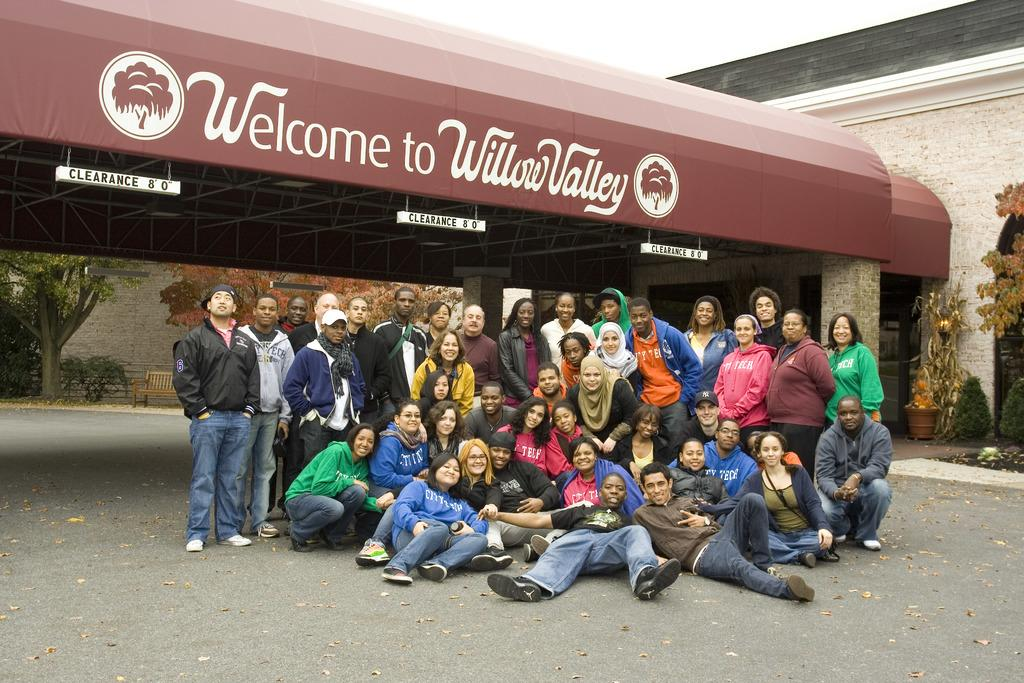What is the main subject of the image? There is a group of people in the middle of the image. What can be seen in the background of the image? There is a shelter, trees, and a wall in the background of the image. What is visible at the top of the image? The sky is visible at the top of the image. Can you tell me how many snakes are slithering around the group of people in the image? There are no snakes present in the image; the group of people is not interacting with any snakes. 